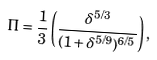<formula> <loc_0><loc_0><loc_500><loc_500>\Pi = { \frac { 1 } { 3 } } \left ( { { \frac { { \delta ^ { 5 / 3 } } } { { ( 1 + \delta ^ { 5 / 9 } ) ^ { 6 / 5 } } } } } \right ) ,</formula> 